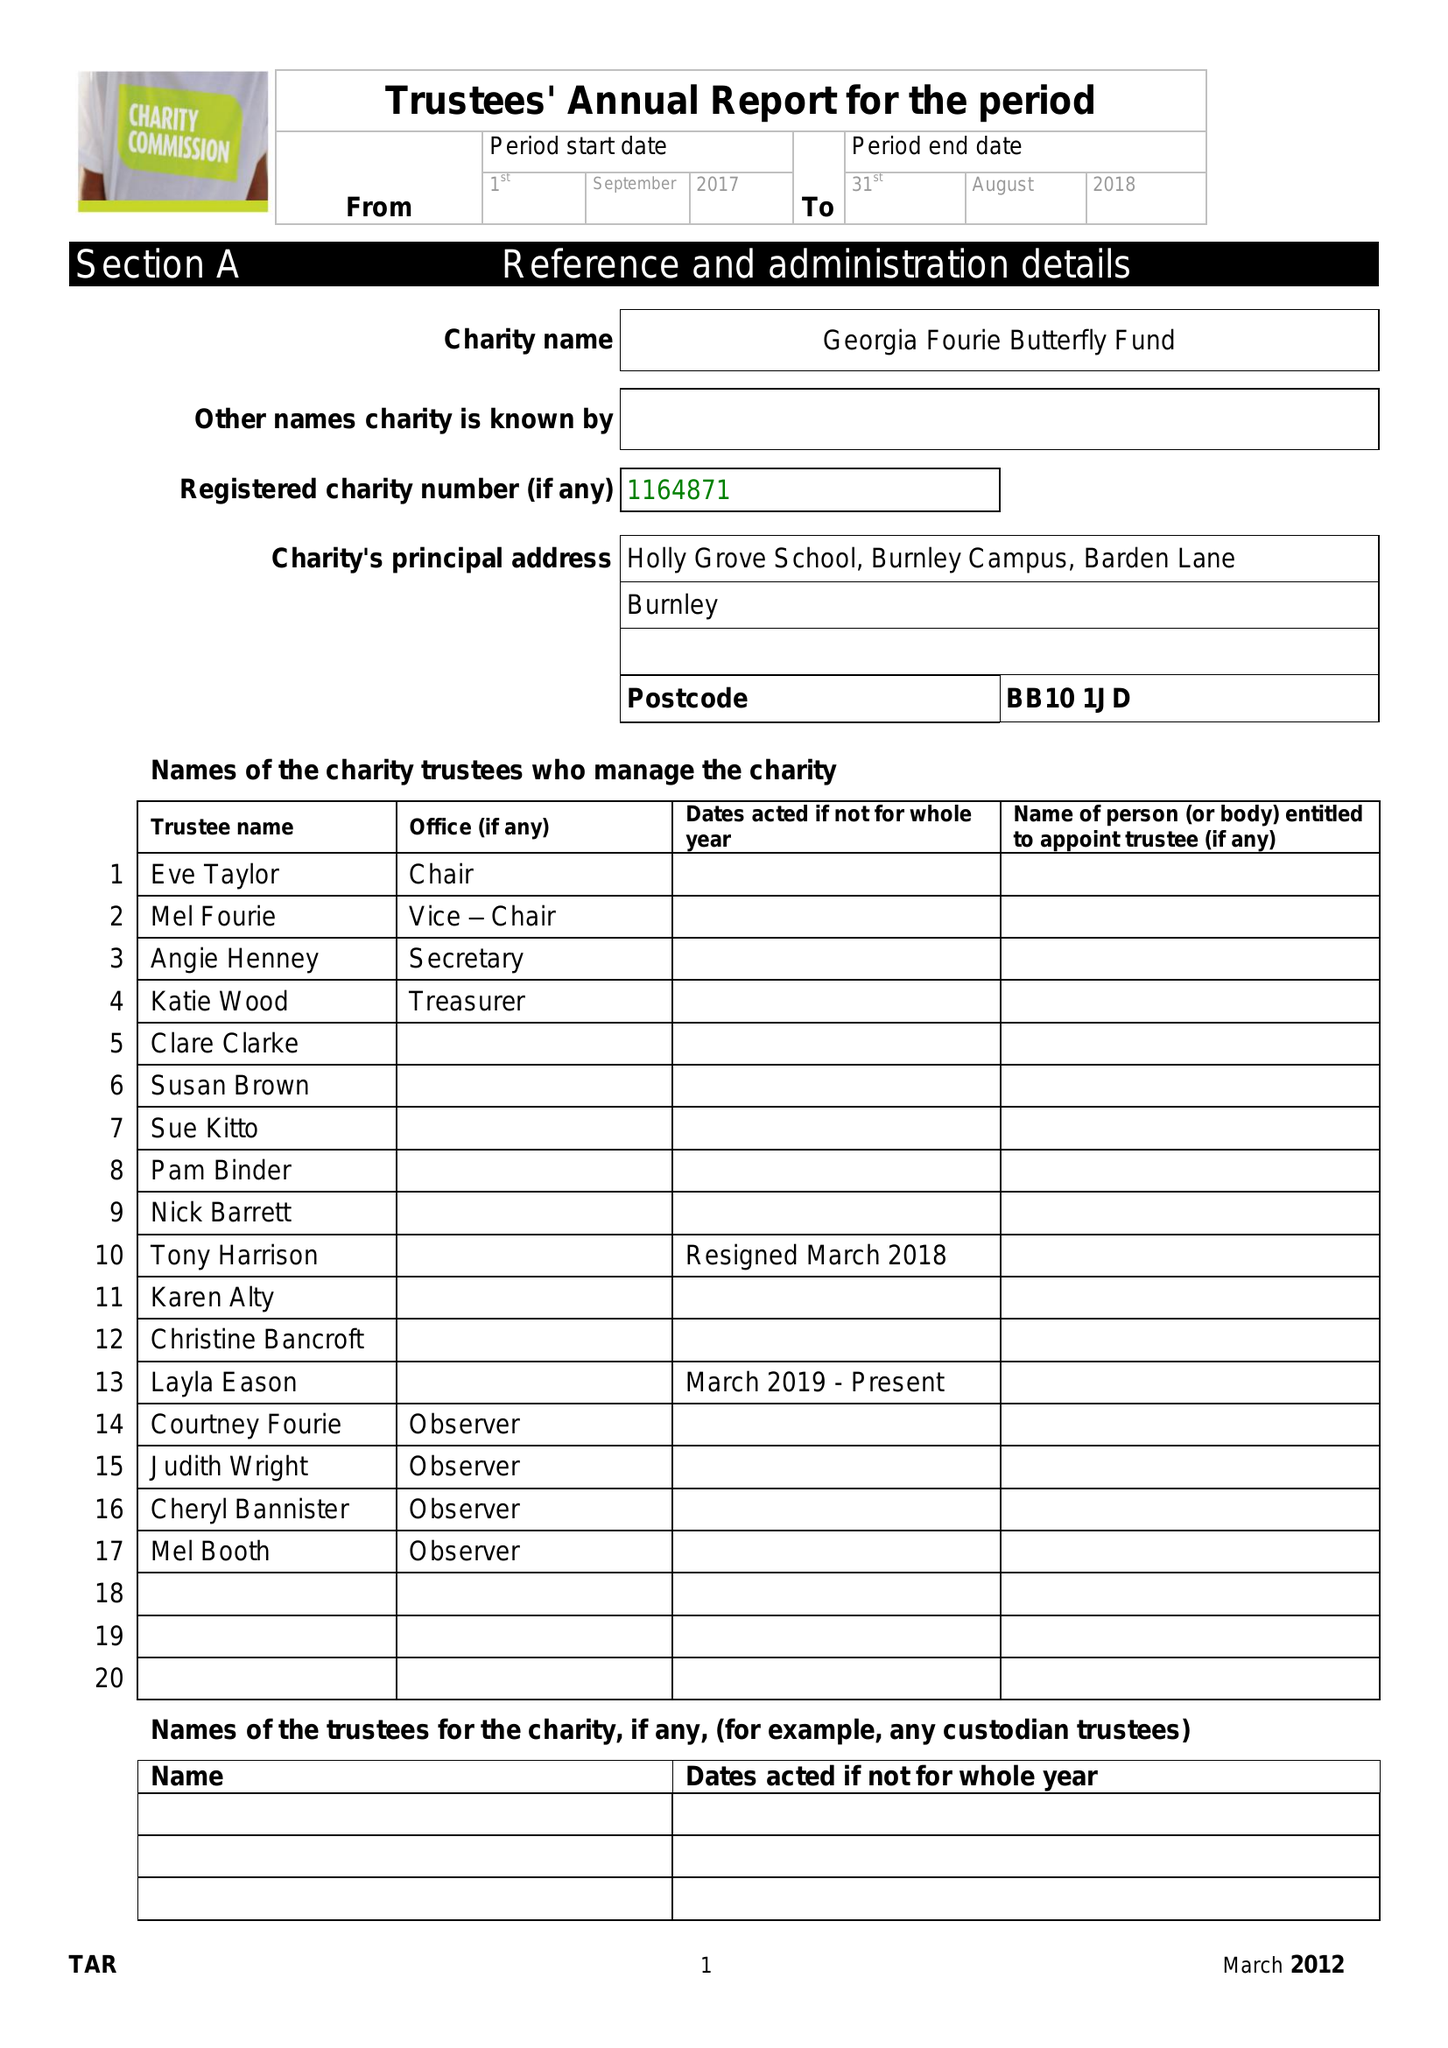What is the value for the address__post_town?
Answer the question using a single word or phrase. BURNLEY 